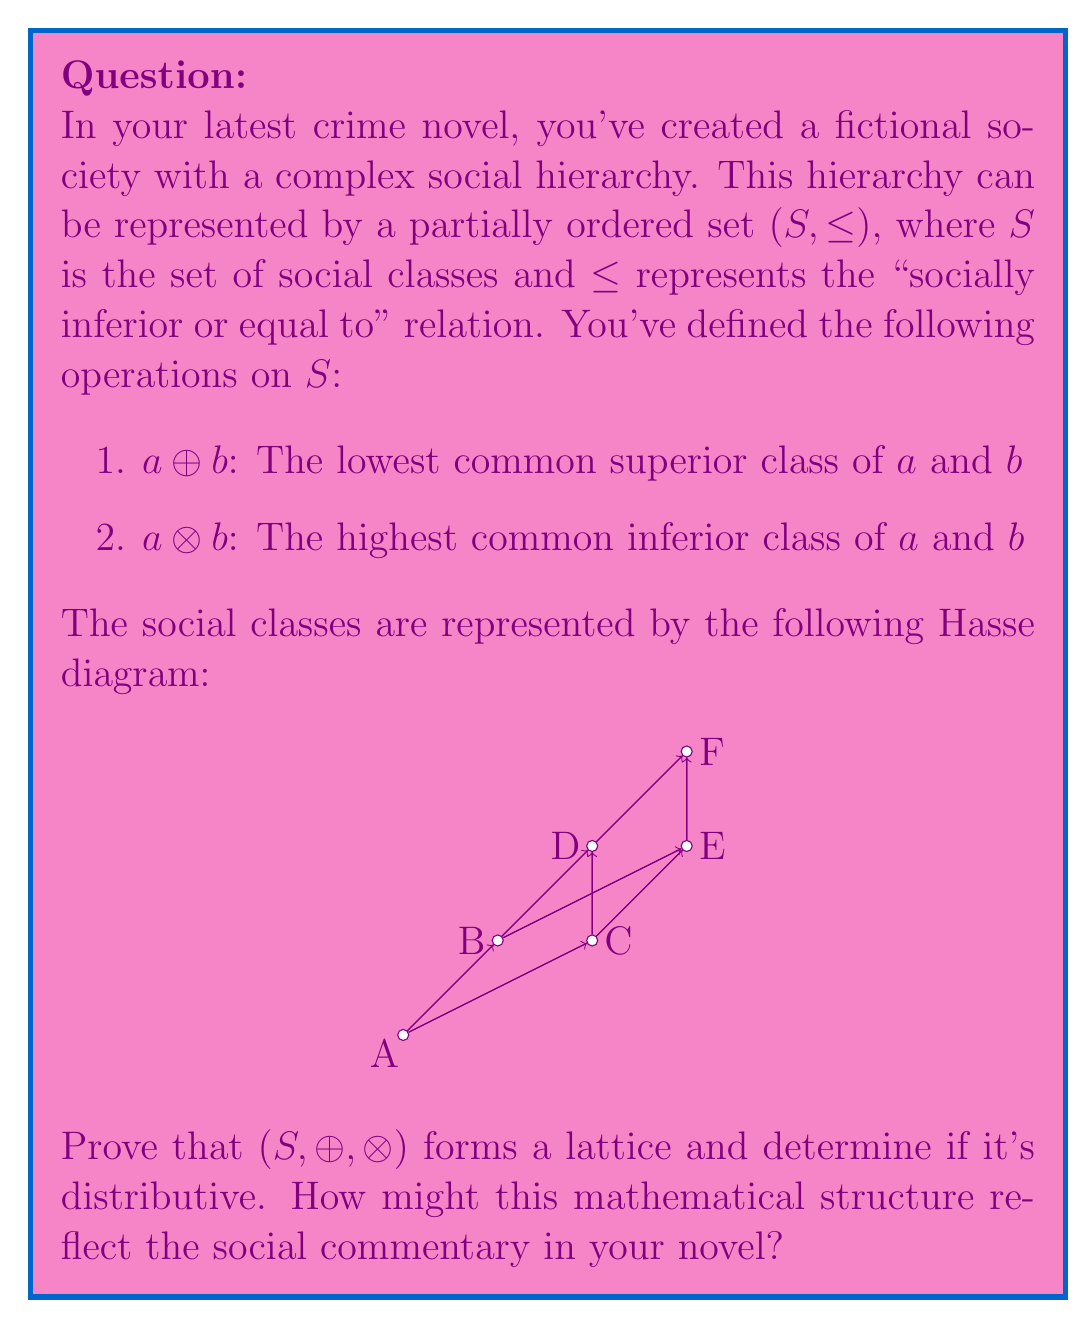Can you solve this math problem? To prove that $(S, \oplus, \otimes)$ forms a lattice and determine if it's distributive, we'll follow these steps:

1. Verify that $(S, \leq)$ is a partially ordered set:
   - Reflexivity: $a \leq a$ for all $a \in S$ (true by definition)
   - Antisymmetry: If $a \leq b$ and $b \leq a$, then $a = b$ (true from the diagram)
   - Transitivity: If $a \leq b$ and $b \leq c$, then $a \leq c$ (true from the diagram)

2. Show that every pair of elements has a least upper bound (LUB) and greatest lower bound (GLB):
   - For any $a, b \in S$, $a \oplus b$ exists (LUB)
   - For any $a, b \in S$, $a \otimes b$ exists (GLB)

3. Verify lattice properties:
   - Commutativity: $a \oplus b = b \oplus a$ and $a \otimes b = b \otimes a$
   - Associativity: $(a \oplus b) \oplus c = a \oplus (b \oplus c)$ and $(a \otimes b) \otimes c = a \otimes (b \otimes c)$
   - Absorption: $a \oplus (a \otimes b) = a$ and $a \otimes (a \oplus b) = a$

4. Check for distributivity:
   - $a \otimes (b \oplus c) = (a \otimes b) \oplus (a \otimes c)$
   - $a \oplus (b \otimes c) = (a \oplus b) \otimes (a \oplus c)$

From the Hasse diagram, we can verify that every pair of elements has a LUB and GLB. For example:
- $B \oplus C = D$
- $B \otimes C = A$

The lattice properties hold for this structure. For instance:
- Commutativity: $B \oplus C = C \oplus B = D$
- Associativity: $(A \oplus B) \oplus C = B \oplus C = D = A \oplus D = A \oplus (B \oplus C)$
- Absorption: $B \oplus (B \otimes C) = B \oplus A = B$

To check distributivity, let's consider an example:
$B \otimes (C \oplus E) = B \otimes E = B$
$(B \otimes C) \oplus (B \otimes E) = A \oplus B = B$

This property holds for all elements, so the lattice is distributive.

The mathematical structure reflects social commentary by representing a rigid hierarchy where:
1. Every pair of social classes has a common superior and inferior class.
2. The structure is distributive, implying a consistent and predictable social order.
3. The limited number of levels suggests a stratified society with clear boundaries between classes.
Answer: $(S, \oplus, \otimes)$ forms a distributive lattice. 